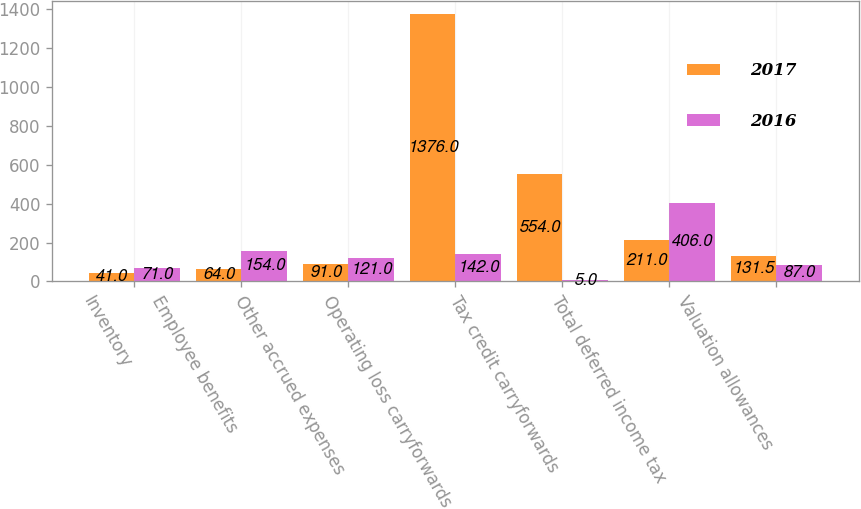<chart> <loc_0><loc_0><loc_500><loc_500><stacked_bar_chart><ecel><fcel>Inventory<fcel>Employee benefits<fcel>Other accrued expenses<fcel>Operating loss carryforwards<fcel>Tax credit carryforwards<fcel>Total deferred income tax<fcel>Valuation allowances<nl><fcel>2017<fcel>41<fcel>64<fcel>91<fcel>1376<fcel>554<fcel>211<fcel>131.5<nl><fcel>2016<fcel>71<fcel>154<fcel>121<fcel>142<fcel>5<fcel>406<fcel>87<nl></chart> 